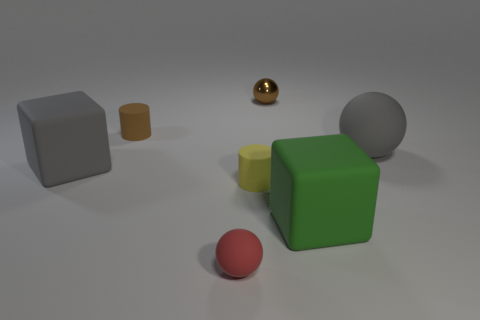Add 1 tiny gray cubes. How many objects exist? 8 Subtract all cubes. How many objects are left? 5 Subtract all purple rubber cylinders. Subtract all tiny spheres. How many objects are left? 5 Add 7 big gray matte spheres. How many big gray matte spheres are left? 8 Add 7 brown spheres. How many brown spheres exist? 8 Subtract 0 purple cubes. How many objects are left? 7 